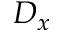<formula> <loc_0><loc_0><loc_500><loc_500>D _ { x }</formula> 